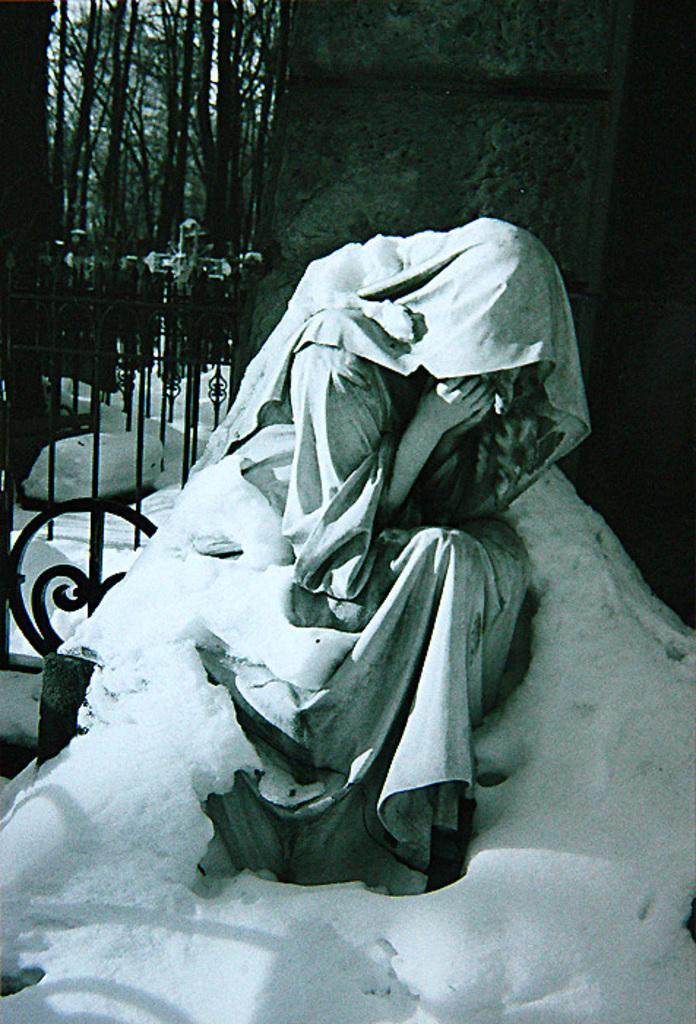How would you summarize this image in a sentence or two? In this image there is a sculpture of person partially covered with snow behind them there is a fence and trees. 